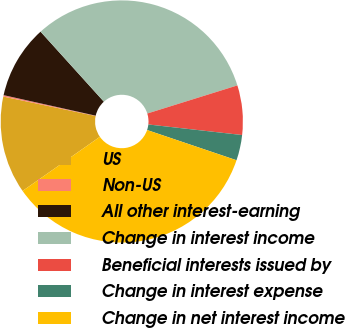Convert chart. <chart><loc_0><loc_0><loc_500><loc_500><pie_chart><fcel>US<fcel>Non-US<fcel>All other interest-earning<fcel>Change in interest income<fcel>Beneficial interests issued by<fcel>Change in interest expense<fcel>Change in net interest income<nl><fcel>13.02%<fcel>0.19%<fcel>9.81%<fcel>31.89%<fcel>6.6%<fcel>3.4%<fcel>35.1%<nl></chart> 